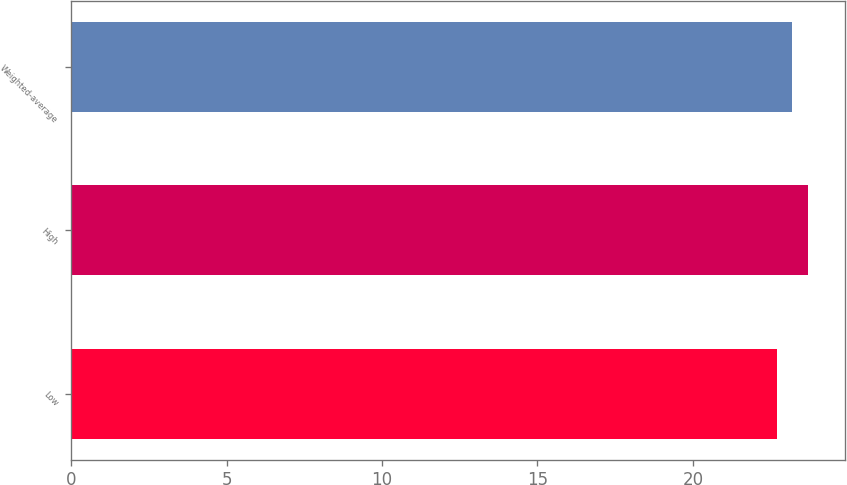Convert chart to OTSL. <chart><loc_0><loc_0><loc_500><loc_500><bar_chart><fcel>Low<fcel>High<fcel>Weighted-average<nl><fcel>22.7<fcel>23.7<fcel>23.2<nl></chart> 